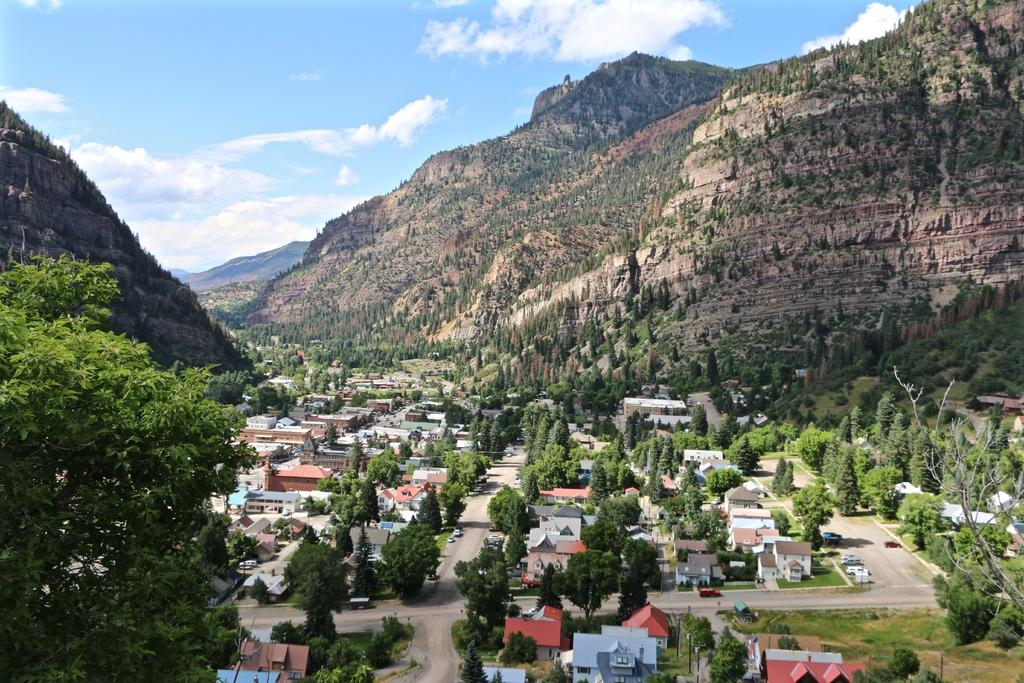What type of structures can be seen in the image? There are houses in the image. What other natural elements are present in the image? There are trees in the image. Are there any man-made objects visible in the image? Yes, there are vehicles in the image. What can be seen in the background of the image? The sky is visible in the background of the image. What is the condition of the sky in the image? Clouds are present in the sky. Can you tell me how many loaves of bread are floating in the water in the image? There is no boat or bread present in the image; it features houses, trees, vehicles, and a sky with clouds. 